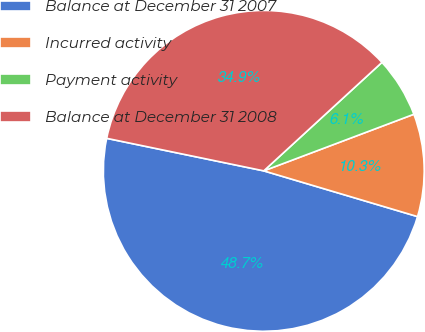Convert chart. <chart><loc_0><loc_0><loc_500><loc_500><pie_chart><fcel>Balance at December 31 2007<fcel>Incurred activity<fcel>Payment activity<fcel>Balance at December 31 2008<nl><fcel>48.65%<fcel>10.34%<fcel>6.08%<fcel>34.93%<nl></chart> 